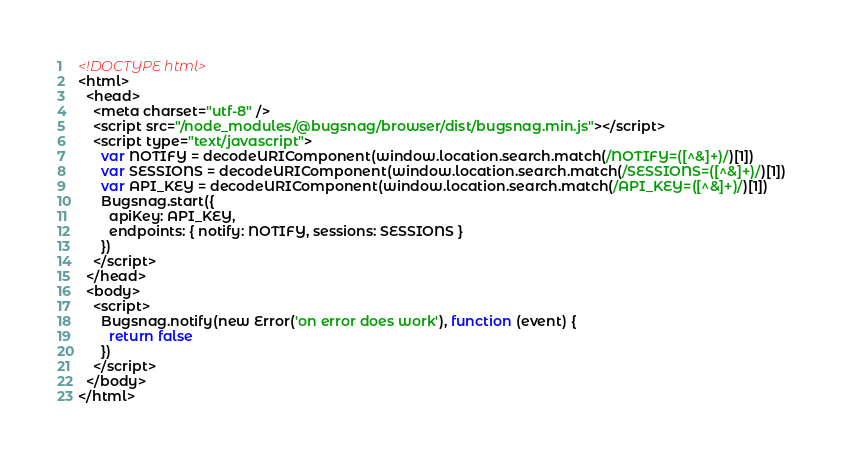Convert code to text. <code><loc_0><loc_0><loc_500><loc_500><_HTML_><!DOCTYPE html>
<html>
  <head>
    <meta charset="utf-8" />
    <script src="/node_modules/@bugsnag/browser/dist/bugsnag.min.js"></script>
    <script type="text/javascript">
      var NOTIFY = decodeURIComponent(window.location.search.match(/NOTIFY=([^&]+)/)[1])
      var SESSIONS = decodeURIComponent(window.location.search.match(/SESSIONS=([^&]+)/)[1])
      var API_KEY = decodeURIComponent(window.location.search.match(/API_KEY=([^&]+)/)[1])
      Bugsnag.start({
        apiKey: API_KEY,
        endpoints: { notify: NOTIFY, sessions: SESSIONS }
      })
    </script>
  </head>
  <body>
    <script>
      Bugsnag.notify(new Error('on error does work'), function (event) {
        return false
      })
    </script>
  </body>
</html>
</code> 